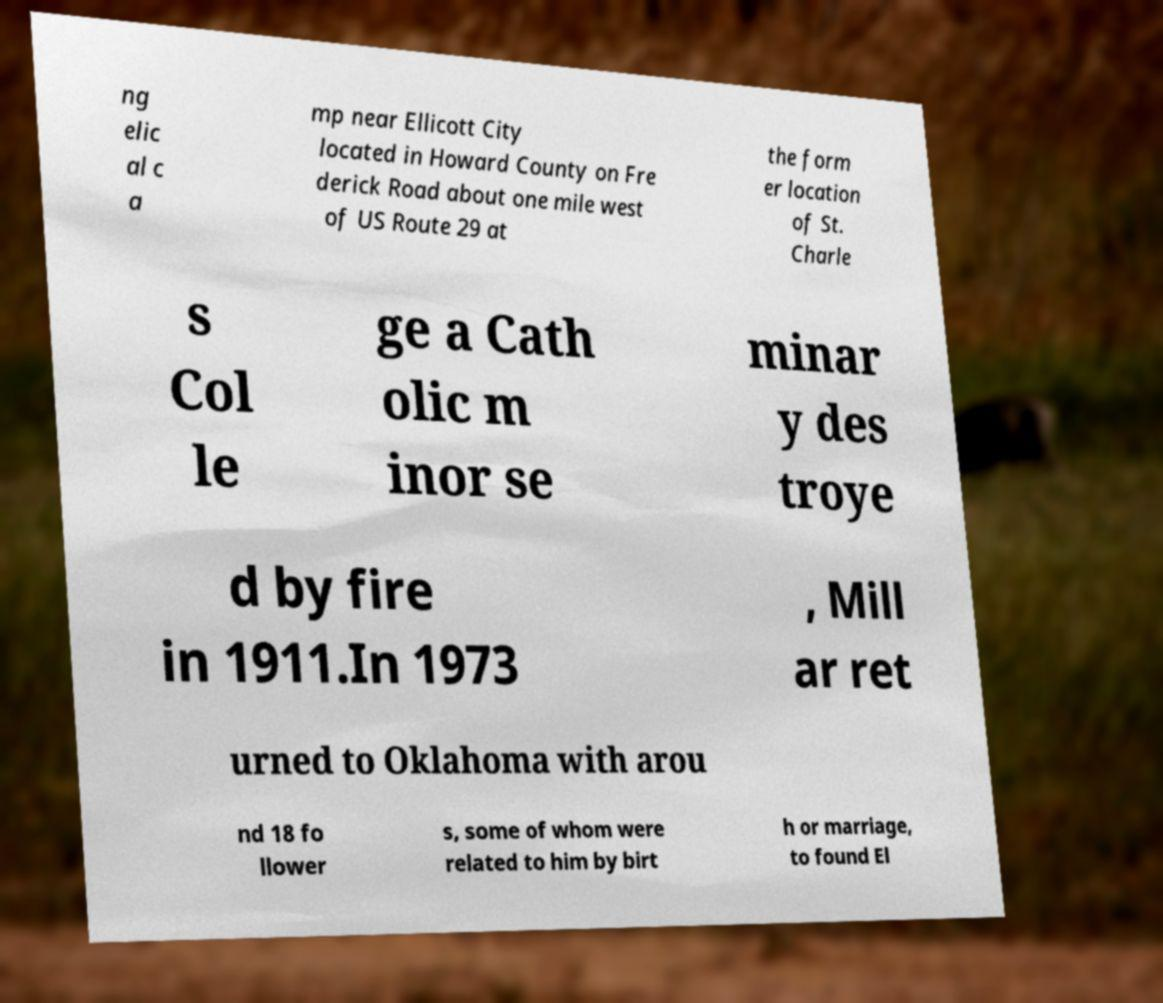Can you accurately transcribe the text from the provided image for me? ng elic al c a mp near Ellicott City located in Howard County on Fre derick Road about one mile west of US Route 29 at the form er location of St. Charle s Col le ge a Cath olic m inor se minar y des troye d by fire in 1911.In 1973 , Mill ar ret urned to Oklahoma with arou nd 18 fo llower s, some of whom were related to him by birt h or marriage, to found El 